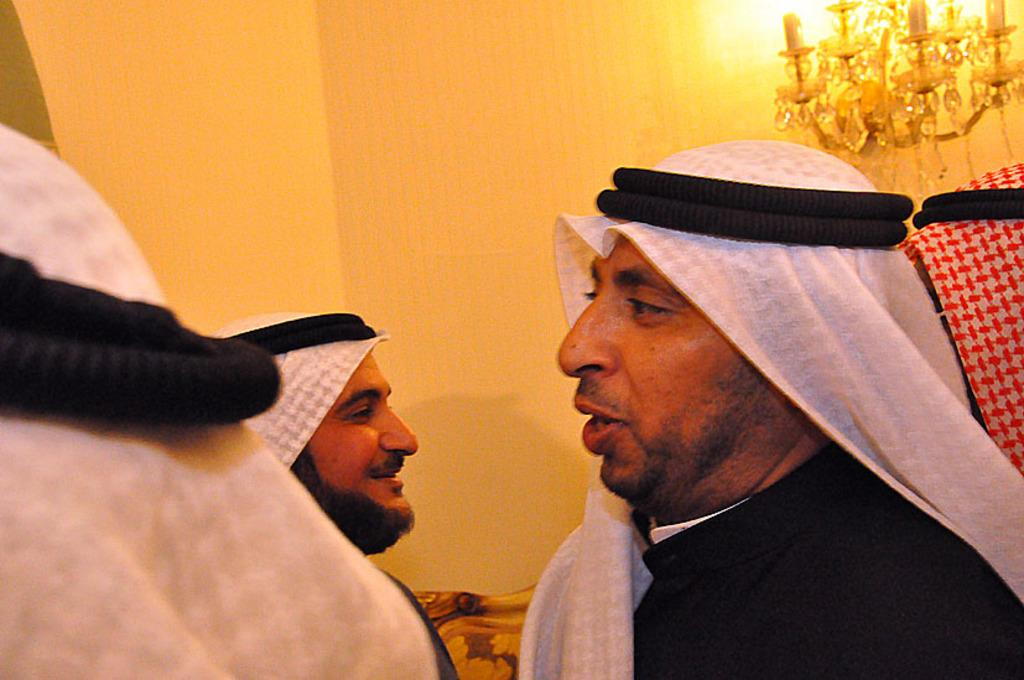Who is present in the image? There is a man in the image. What is the man wearing? The man is wearing a black dress. What is the man doing in the image? The man is talking. How many people are in the image? There are three people in the image. What can be seen in the background of the image? There appears to be a chair in the background of the image. What is visible at the top of the image? There is a chandelier visible at the top of the image. What type of class is the man teaching in the image? There is no indication in the image that the man is teaching a class. 